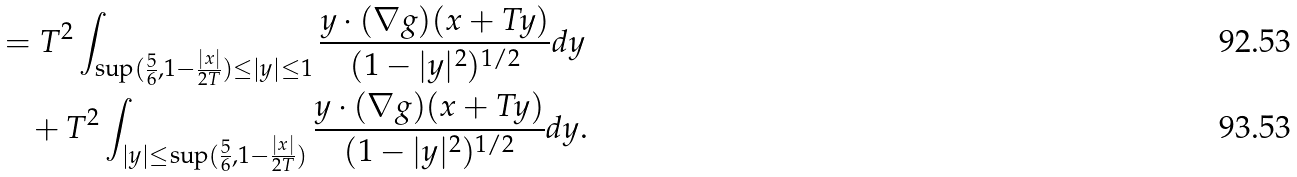Convert formula to latex. <formula><loc_0><loc_0><loc_500><loc_500>& = T ^ { 2 } \int _ { \sup ( \frac { 5 } { 6 } , 1 - \frac { | x | } { 2 T } ) \leq | y | \leq 1 } \frac { y \cdot ( \nabla g ) ( x + T y ) } { ( 1 - | y | ^ { 2 } ) ^ { 1 / 2 } } d y \\ & \quad + T ^ { 2 } \int _ { | y | \leq \sup ( \frac { 5 } { 6 } , 1 - \frac { | x | } { 2 T } ) } \frac { y \cdot ( \nabla g ) ( x + T y ) } { ( 1 - | y | ^ { 2 } ) ^ { 1 / 2 } } d y .</formula> 